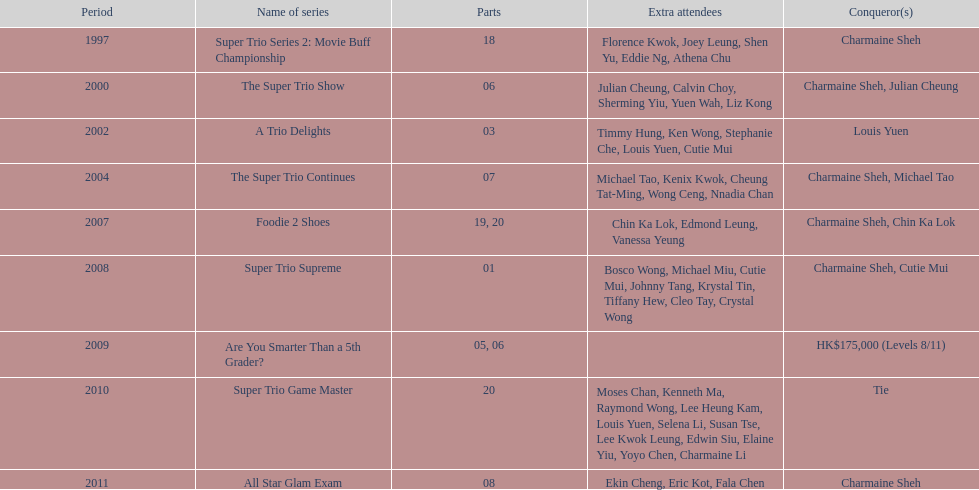What was the total number of trio series shows were charmaine sheh on? 6. 